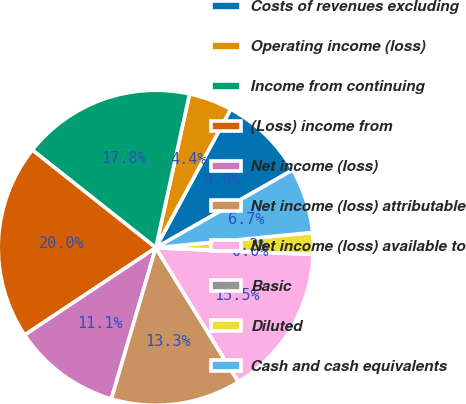Convert chart to OTSL. <chart><loc_0><loc_0><loc_500><loc_500><pie_chart><fcel>Costs of revenues excluding<fcel>Operating income (loss)<fcel>Income from continuing<fcel>(Loss) income from<fcel>Net income (loss)<fcel>Net income (loss) attributable<fcel>Net income (loss) available to<fcel>Basic<fcel>Diluted<fcel>Cash and cash equivalents<nl><fcel>8.89%<fcel>4.45%<fcel>17.78%<fcel>20.0%<fcel>11.11%<fcel>13.33%<fcel>15.55%<fcel>0.0%<fcel>2.22%<fcel>6.67%<nl></chart> 